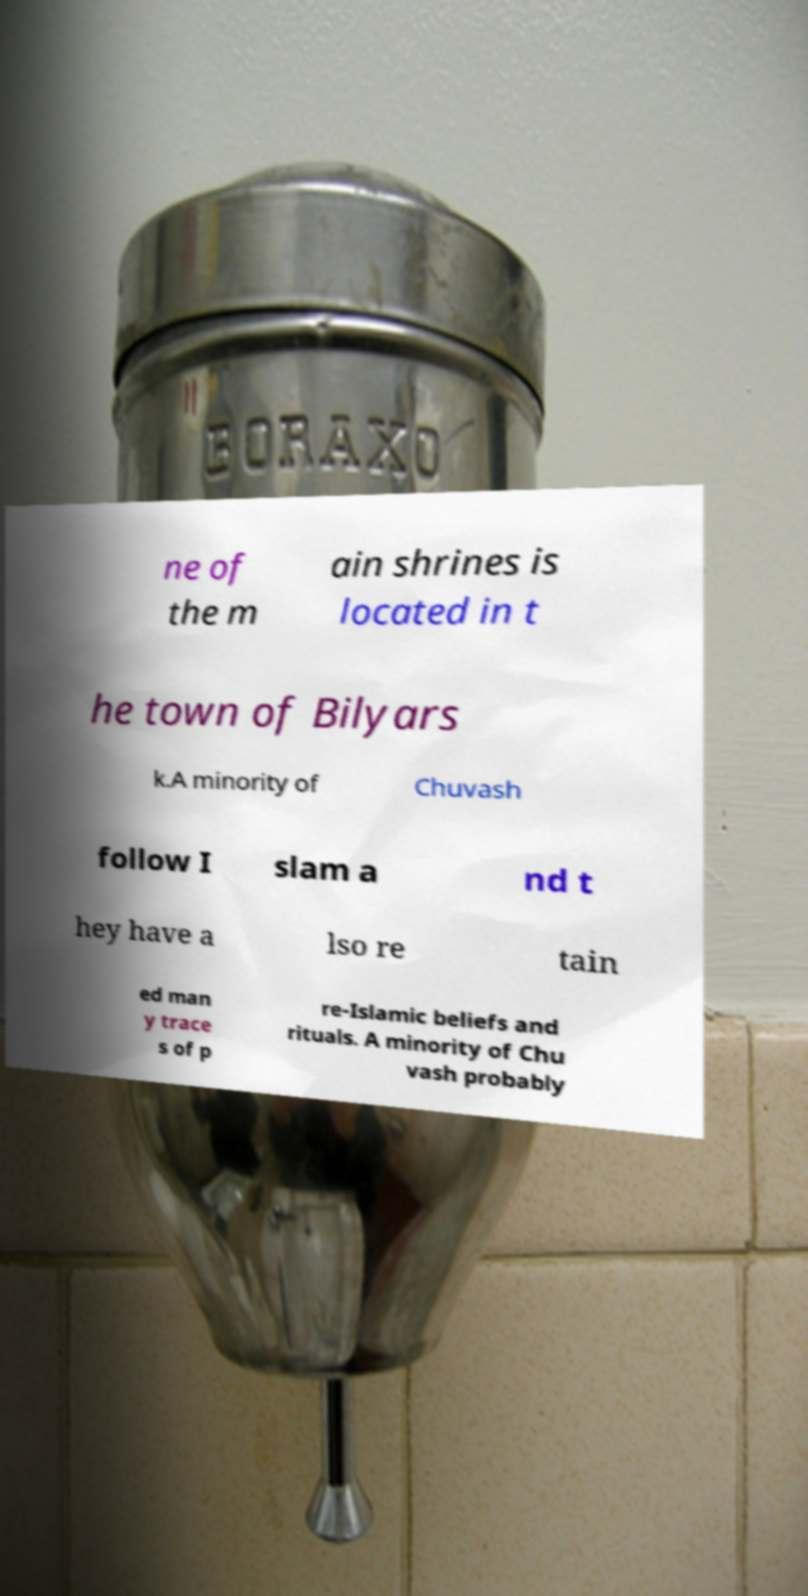Please identify and transcribe the text found in this image. ne of the m ain shrines is located in t he town of Bilyars k.A minority of Chuvash follow I slam a nd t hey have a lso re tain ed man y trace s of p re-Islamic beliefs and rituals. A minority of Chu vash probably 